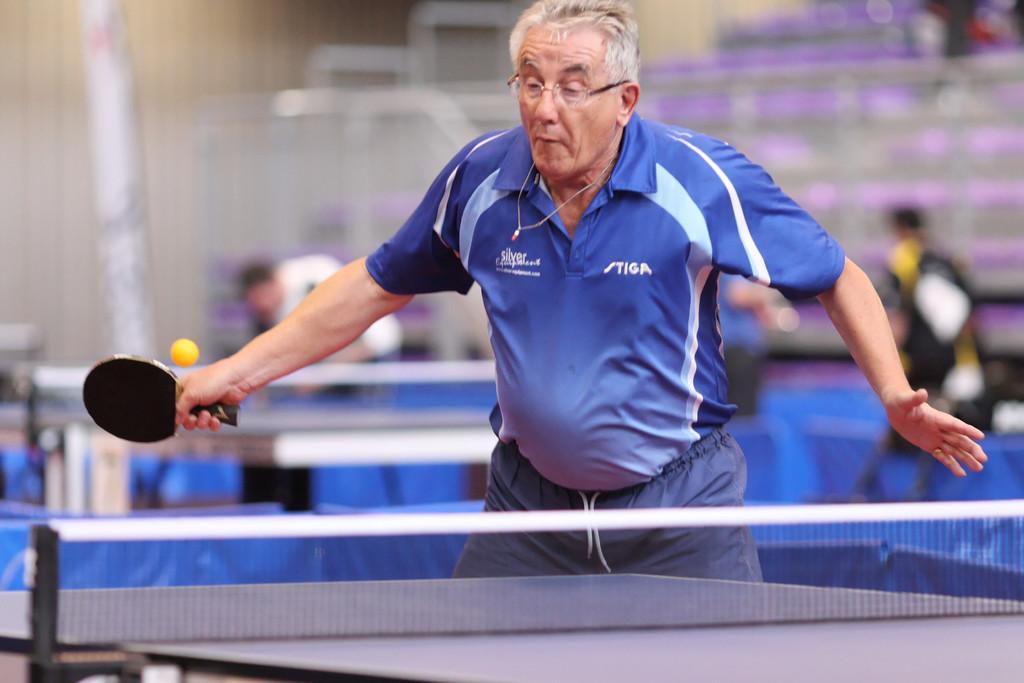Describe this image in one or two sentences. In this picture we can see an old man playing table tennis with someone. 